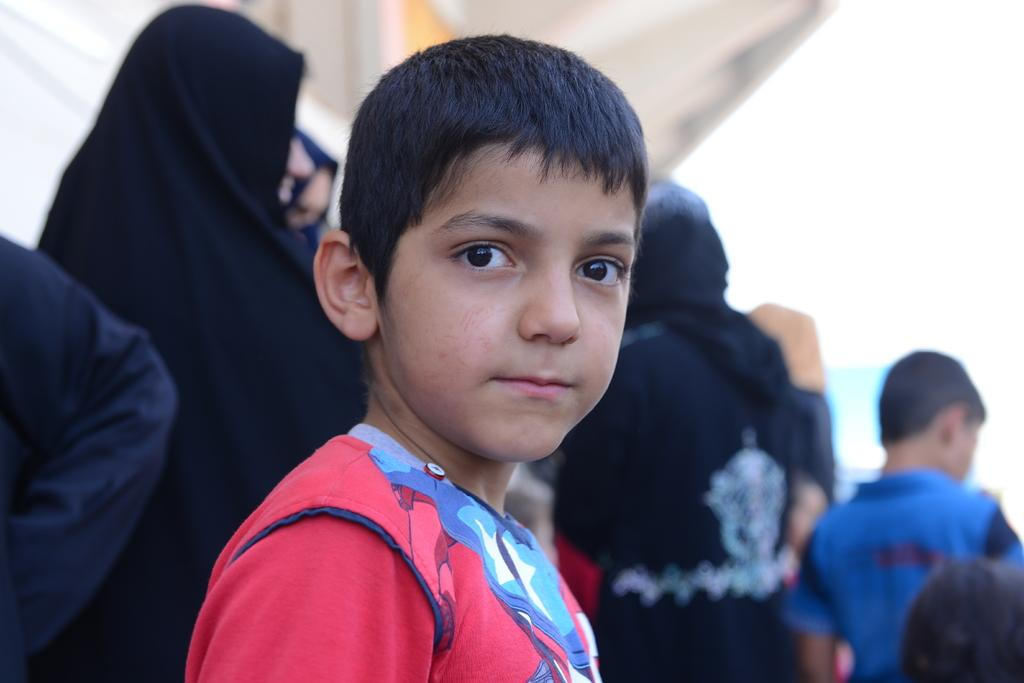What is the main subject of the image? There is a boy standing in the image. Can you describe the background of the image? There are people standing in the background of the image. What part of a person can be seen on the left side of the image? There is a person's hand visible on the left side of the image. What type of popcorn is being served for lunch in the image? There is no popcorn or lunch being served in the image. What mark can be seen on the boy's shirt in the image? There is no mark visible on the boy's shirt in the image. 